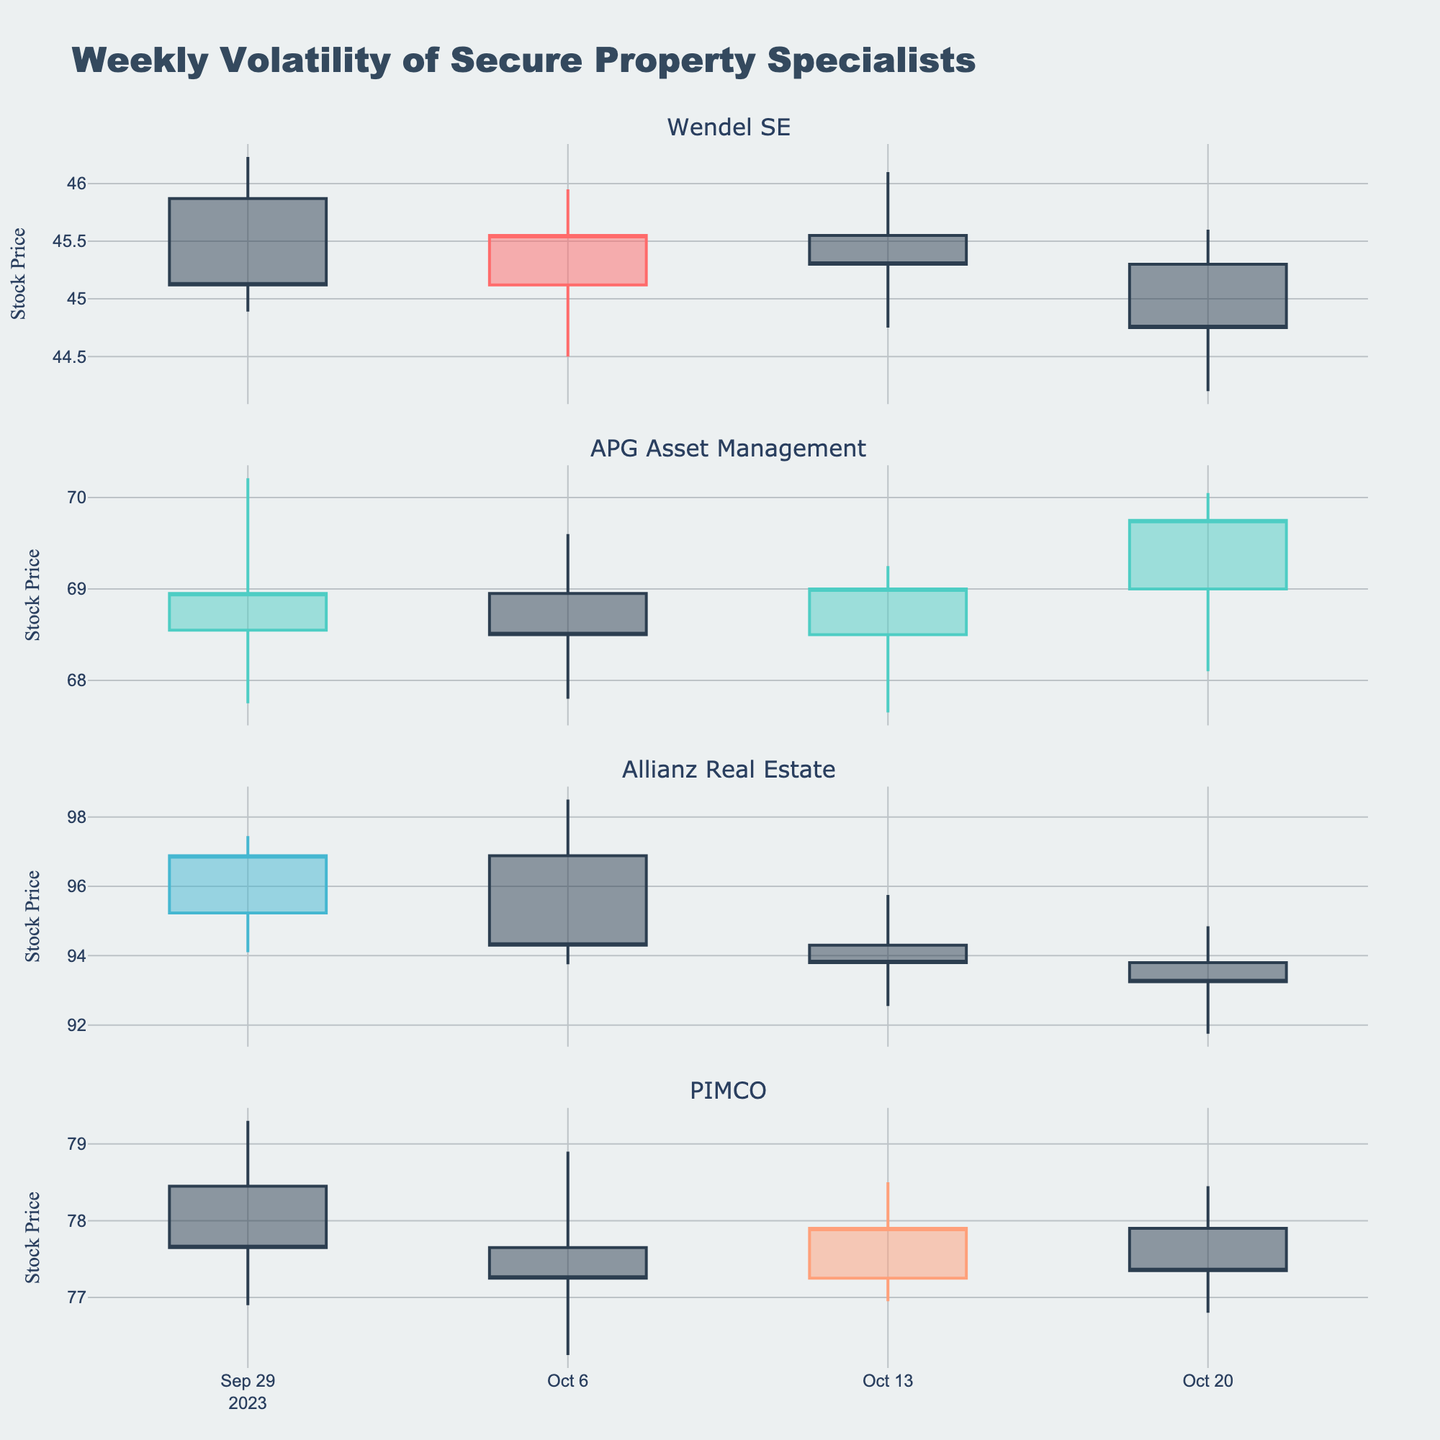Which company has the highest closing price on 2023-09-29? Check the closing prices for each company on 2023-09-29. Allianz Real Estate has the highest closing price at 96.88.
Answer: Allianz Real Estate Which company has displayed the most consistent closing prices over the weeks? Compare the weekly closing prices for each company over the provided dates. Wendel SE has shown relatively consistent closing prices (45.12, 45.55, 45.30, 44.75) compared to other companies.
Answer: Wendel SE Did any company experience a week where the closing price significantly dropped after a previous week's increase? Review the weekly closing prices for each company. Allianz Real Estate closed at 96.88 on 2023-09-29, then 94.3 on 2023-10-06 (a drop from the previous week), after an increase from 95.23 to 96.88 the weeks before.
Answer: Allianz Real Estate Which company had the highest weekly volatility between 2023-10-06 and 2023-10-13? Calculate the high-low range for the week between 2023-10-06 and 2023-10-13 for each company. Allianz Real Estate had the highest volatility with a range (95.75-92.55) of 3.20.
Answer: Allianz Real Estate Which company had the most volatile closing prices between the weeks of 2023-09-29 and 2023-10-20? Compare the range of closing prices for each company over the whole period. Allianz Real Estate’s closing prices ranged from 96.88 to 93.25, a difference of 3.63, which is the highest among all companies.
Answer: Allianz Real Estate What is the overall trend in Wendel SE's stock prices over the four weeks? Examine the stock prices for Wendel SE over the weeks. There is a slight downward trend from 45.12 to 44.75 over the period.
Answer: Slight downward trend Compare the highest stock price reached by APG Asset Management and PIMCO. Which is higher? Check the highest prices reached by APG Asset Management (70.21) and PIMCO (79.30). PIMCO's highest price (79.30) is higher than APG Asset Management's.
Answer: PIMCO By how much did the closing price for Allianz Real Estate fall from the week of 2023-09-29 to the week of 2023-10-20? Subtract the closing price on 2023-09-29 (96.88) from that on 2023-10-20 (93.25). This is a fall of 96.88 - 93.25 = 3.63.
Answer: 3.63 What week did PIMCO achieve its lowest closing price, and what was the price? Identify the lowest closing price for PIMCO across the weeks. The lowest closing price was 77.25 on 2023-10-06.
Answer: 2023-10-06, 77.25 Which company showed an increasing closing price trend over the period given? Compare the initial and final closing prices to identify any upward trend. APG Asset Management had a closing price increasing from 68.95 to 69.75.
Answer: APG Asset Management 